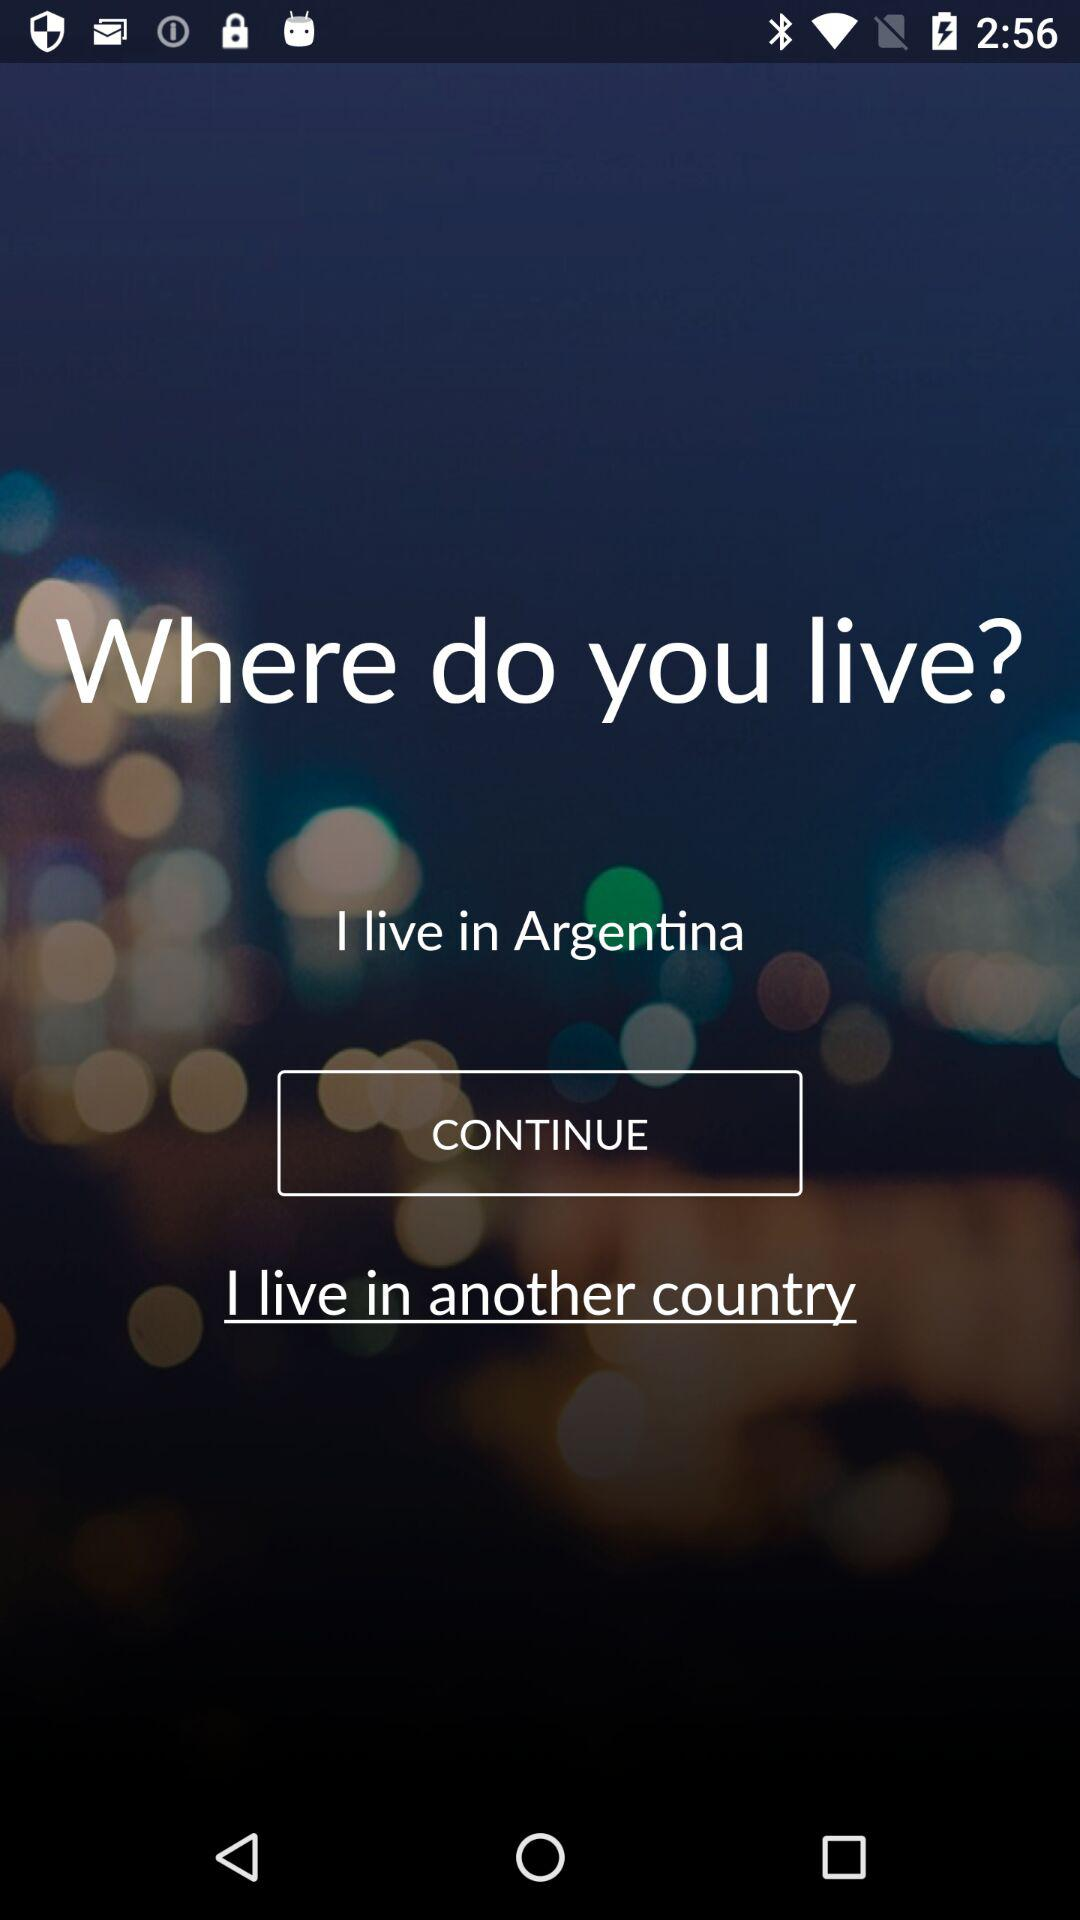What is the live location? The live location is "Argentina". 